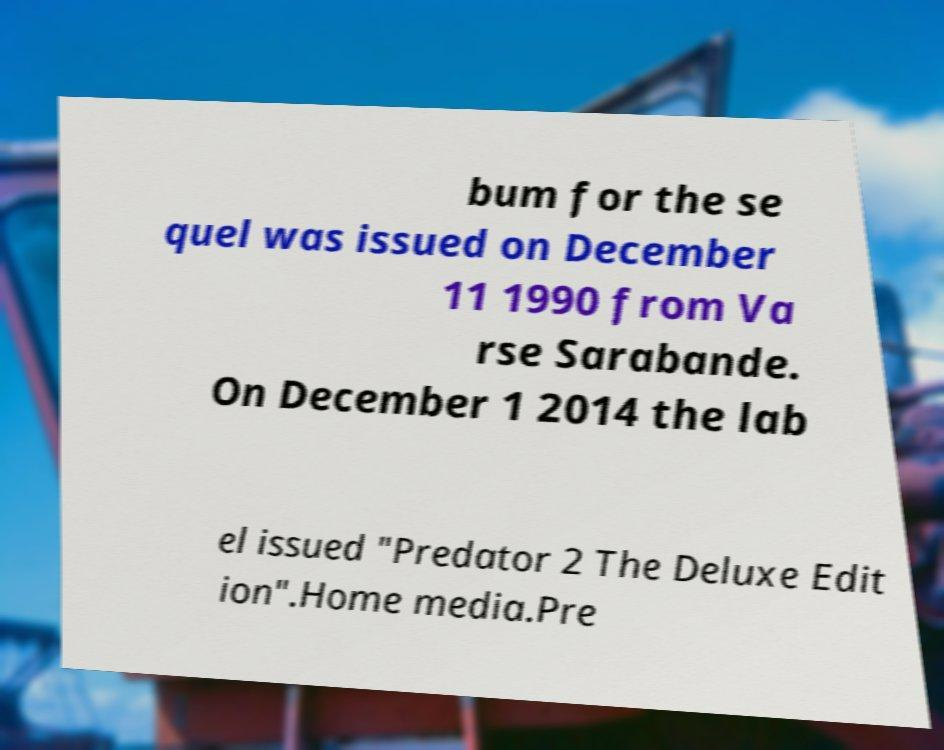There's text embedded in this image that I need extracted. Can you transcribe it verbatim? bum for the se quel was issued on December 11 1990 from Va rse Sarabande. On December 1 2014 the lab el issued "Predator 2 The Deluxe Edit ion".Home media.Pre 